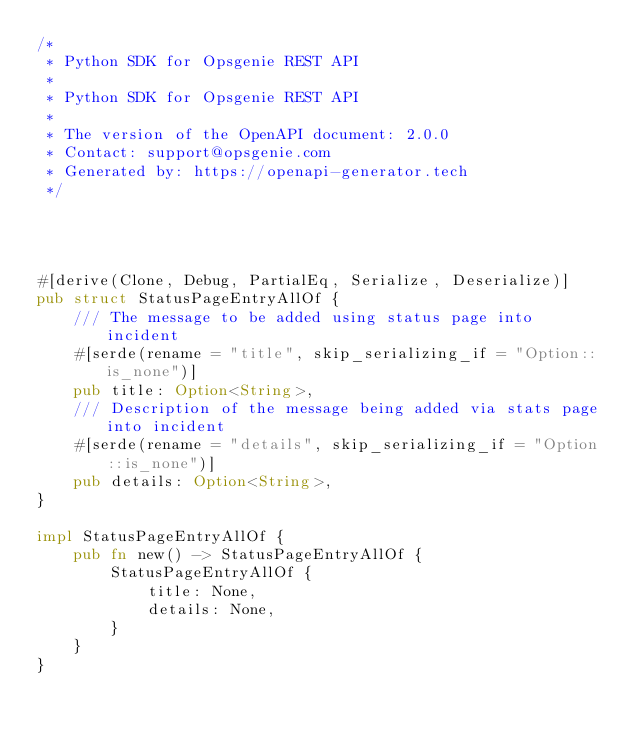<code> <loc_0><loc_0><loc_500><loc_500><_Rust_>/*
 * Python SDK for Opsgenie REST API
 *
 * Python SDK for Opsgenie REST API
 *
 * The version of the OpenAPI document: 2.0.0
 * Contact: support@opsgenie.com
 * Generated by: https://openapi-generator.tech
 */




#[derive(Clone, Debug, PartialEq, Serialize, Deserialize)]
pub struct StatusPageEntryAllOf {
    /// The message to be added using status page into incident
    #[serde(rename = "title", skip_serializing_if = "Option::is_none")]
    pub title: Option<String>,
    /// Description of the message being added via stats page into incident
    #[serde(rename = "details", skip_serializing_if = "Option::is_none")]
    pub details: Option<String>,
}

impl StatusPageEntryAllOf {
    pub fn new() -> StatusPageEntryAllOf {
        StatusPageEntryAllOf {
            title: None,
            details: None,
        }
    }
}


</code> 